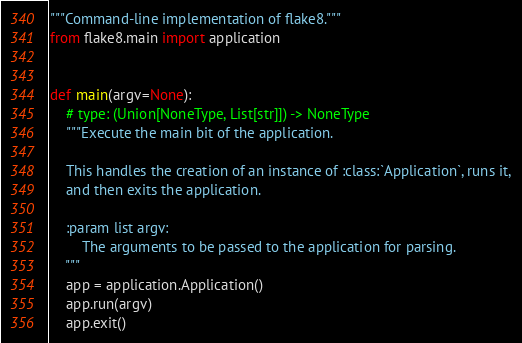Convert code to text. <code><loc_0><loc_0><loc_500><loc_500><_Python_>"""Command-line implementation of flake8."""
from flake8.main import application


def main(argv=None):
    # type: (Union[NoneType, List[str]]) -> NoneType
    """Execute the main bit of the application.

    This handles the creation of an instance of :class:`Application`, runs it,
    and then exits the application.

    :param list argv:
        The arguments to be passed to the application for parsing.
    """
    app = application.Application()
    app.run(argv)
    app.exit()
</code> 